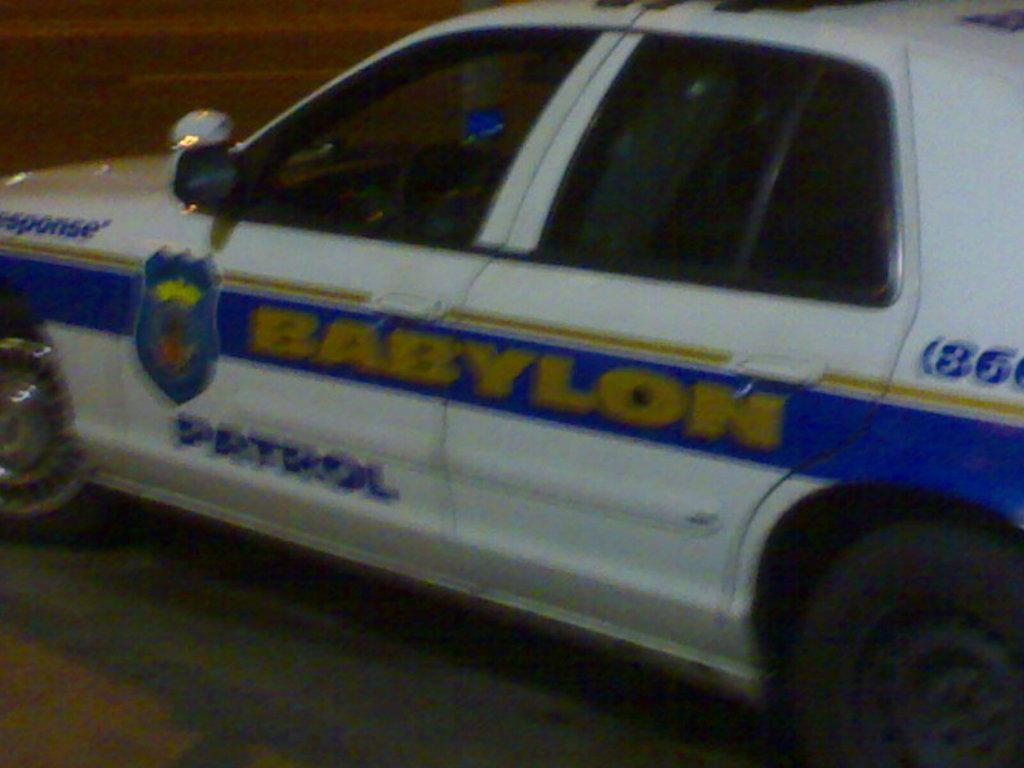<image>
Give a short and clear explanation of the subsequent image. a car that has the word patrol on the side 